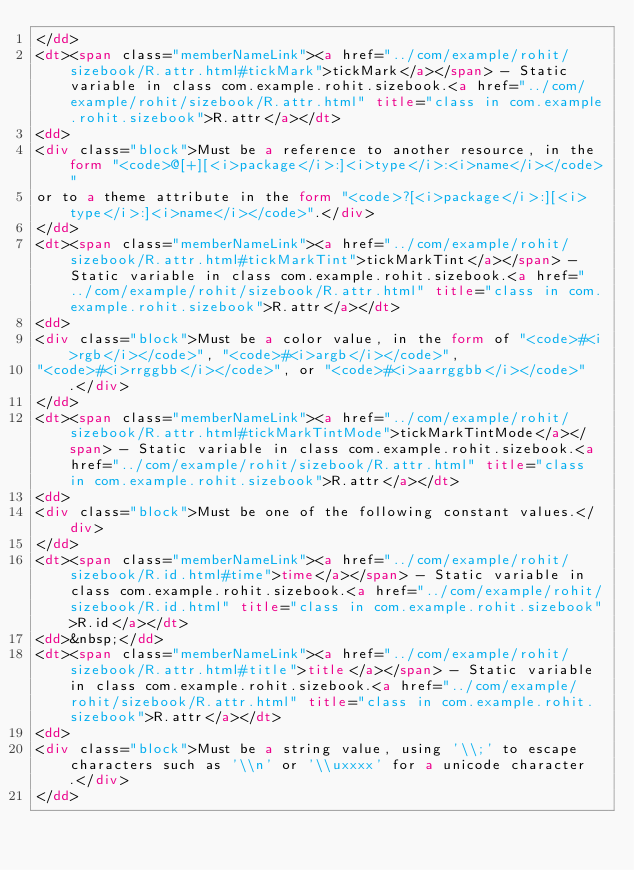Convert code to text. <code><loc_0><loc_0><loc_500><loc_500><_HTML_></dd>
<dt><span class="memberNameLink"><a href="../com/example/rohit/sizebook/R.attr.html#tickMark">tickMark</a></span> - Static variable in class com.example.rohit.sizebook.<a href="../com/example/rohit/sizebook/R.attr.html" title="class in com.example.rohit.sizebook">R.attr</a></dt>
<dd>
<div class="block">Must be a reference to another resource, in the form "<code>@[+][<i>package</i>:]<i>type</i>:<i>name</i></code>"
or to a theme attribute in the form "<code>?[<i>package</i>:][<i>type</i>:]<i>name</i></code>".</div>
</dd>
<dt><span class="memberNameLink"><a href="../com/example/rohit/sizebook/R.attr.html#tickMarkTint">tickMarkTint</a></span> - Static variable in class com.example.rohit.sizebook.<a href="../com/example/rohit/sizebook/R.attr.html" title="class in com.example.rohit.sizebook">R.attr</a></dt>
<dd>
<div class="block">Must be a color value, in the form of "<code>#<i>rgb</i></code>", "<code>#<i>argb</i></code>",
"<code>#<i>rrggbb</i></code>", or "<code>#<i>aarrggbb</i></code>".</div>
</dd>
<dt><span class="memberNameLink"><a href="../com/example/rohit/sizebook/R.attr.html#tickMarkTintMode">tickMarkTintMode</a></span> - Static variable in class com.example.rohit.sizebook.<a href="../com/example/rohit/sizebook/R.attr.html" title="class in com.example.rohit.sizebook">R.attr</a></dt>
<dd>
<div class="block">Must be one of the following constant values.</div>
</dd>
<dt><span class="memberNameLink"><a href="../com/example/rohit/sizebook/R.id.html#time">time</a></span> - Static variable in class com.example.rohit.sizebook.<a href="../com/example/rohit/sizebook/R.id.html" title="class in com.example.rohit.sizebook">R.id</a></dt>
<dd>&nbsp;</dd>
<dt><span class="memberNameLink"><a href="../com/example/rohit/sizebook/R.attr.html#title">title</a></span> - Static variable in class com.example.rohit.sizebook.<a href="../com/example/rohit/sizebook/R.attr.html" title="class in com.example.rohit.sizebook">R.attr</a></dt>
<dd>
<div class="block">Must be a string value, using '\\;' to escape characters such as '\\n' or '\\uxxxx' for a unicode character.</div>
</dd></code> 